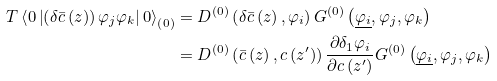<formula> <loc_0><loc_0><loc_500><loc_500>T \left \langle 0 \left | \left ( \delta \bar { c } \left ( z \right ) \right ) \varphi _ { j } \varphi _ { k } \right | 0 \right \rangle _ { \left ( 0 \right ) } & = D ^ { \left ( 0 \right ) } \left ( \delta \bar { c } \left ( z \right ) , \varphi _ { i } \right ) G ^ { \left ( 0 \right ) } \left ( \underline { \varphi _ { i } } , \varphi _ { j } , \varphi _ { k } \right ) \\ & = D ^ { \left ( 0 \right ) } \left ( \bar { c } \left ( z \right ) , c \left ( z ^ { \prime } \right ) \right ) \frac { \partial \delta _ { 1 } \varphi _ { i } } { \partial c \left ( z ^ { \prime } \right ) } G ^ { \left ( 0 \right ) } \left ( \underline { \varphi _ { i } } , \varphi _ { j } , \varphi _ { k } \right )</formula> 